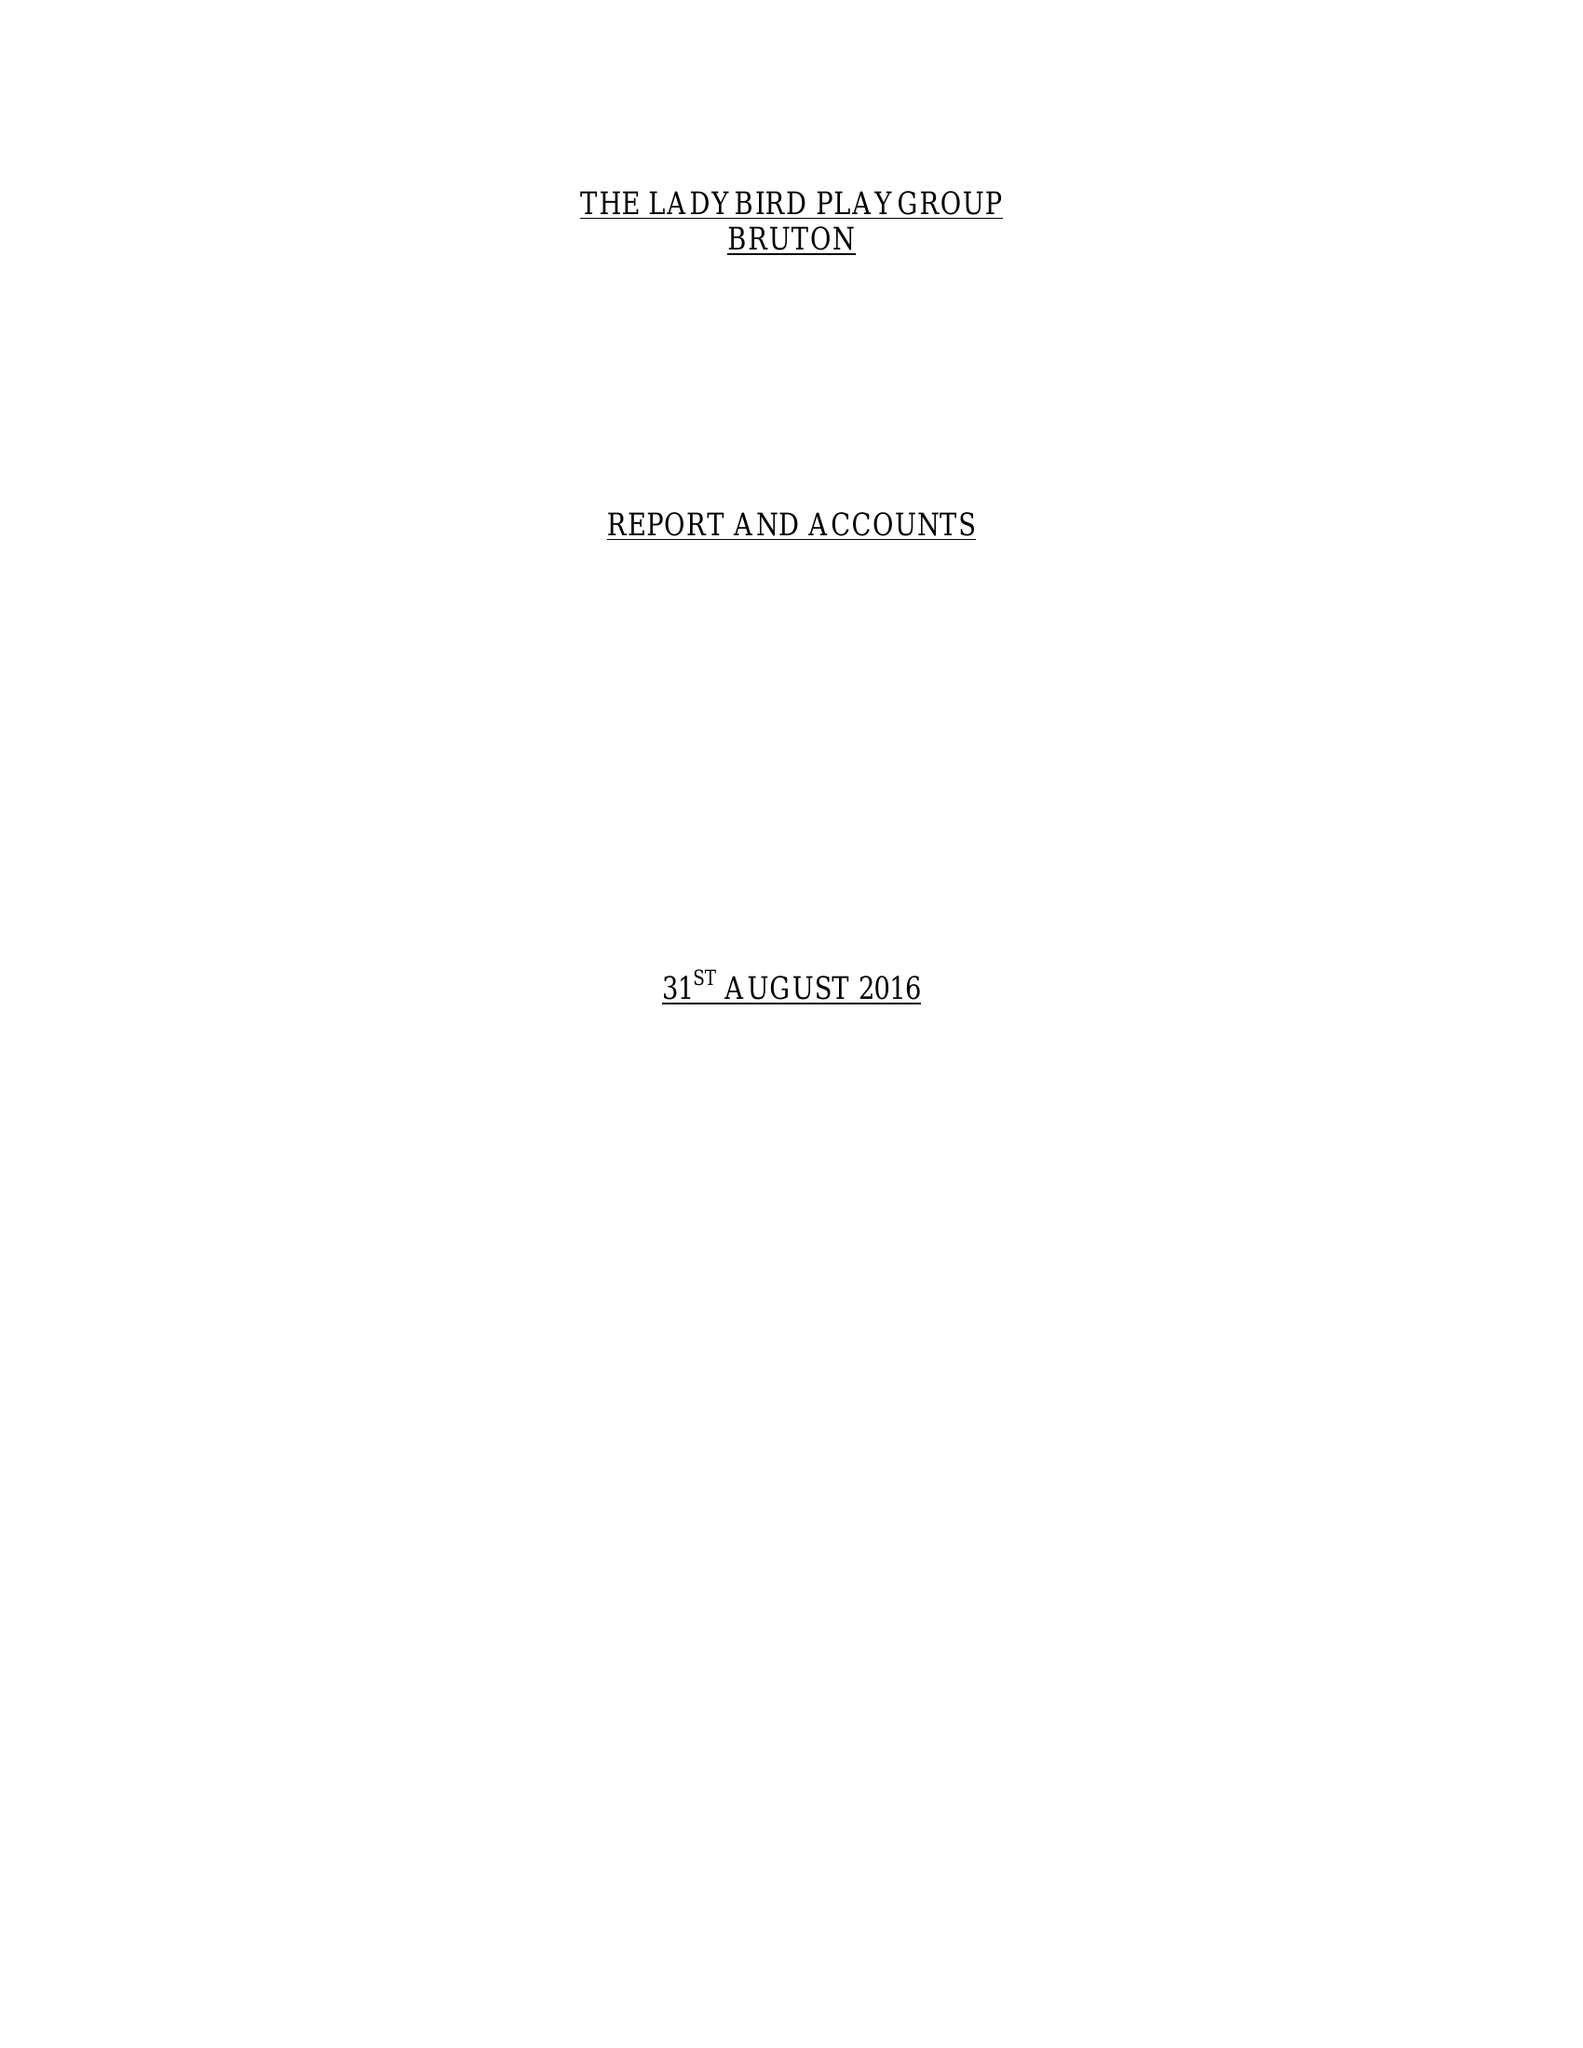What is the value for the address__post_town?
Answer the question using a single word or phrase. BRUTON 